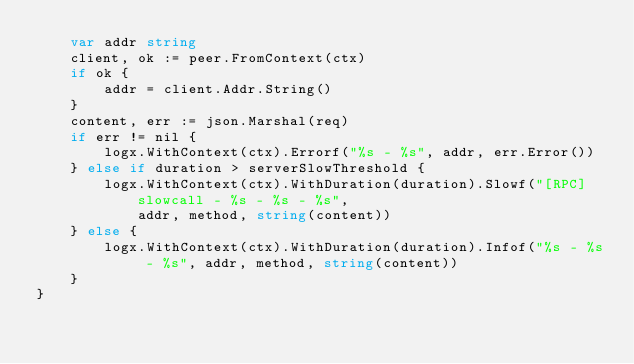<code> <loc_0><loc_0><loc_500><loc_500><_Go_>	var addr string
	client, ok := peer.FromContext(ctx)
	if ok {
		addr = client.Addr.String()
	}
	content, err := json.Marshal(req)
	if err != nil {
		logx.WithContext(ctx).Errorf("%s - %s", addr, err.Error())
	} else if duration > serverSlowThreshold {
		logx.WithContext(ctx).WithDuration(duration).Slowf("[RPC] slowcall - %s - %s - %s",
			addr, method, string(content))
	} else {
		logx.WithContext(ctx).WithDuration(duration).Infof("%s - %s - %s", addr, method, string(content))
	}
}
</code> 